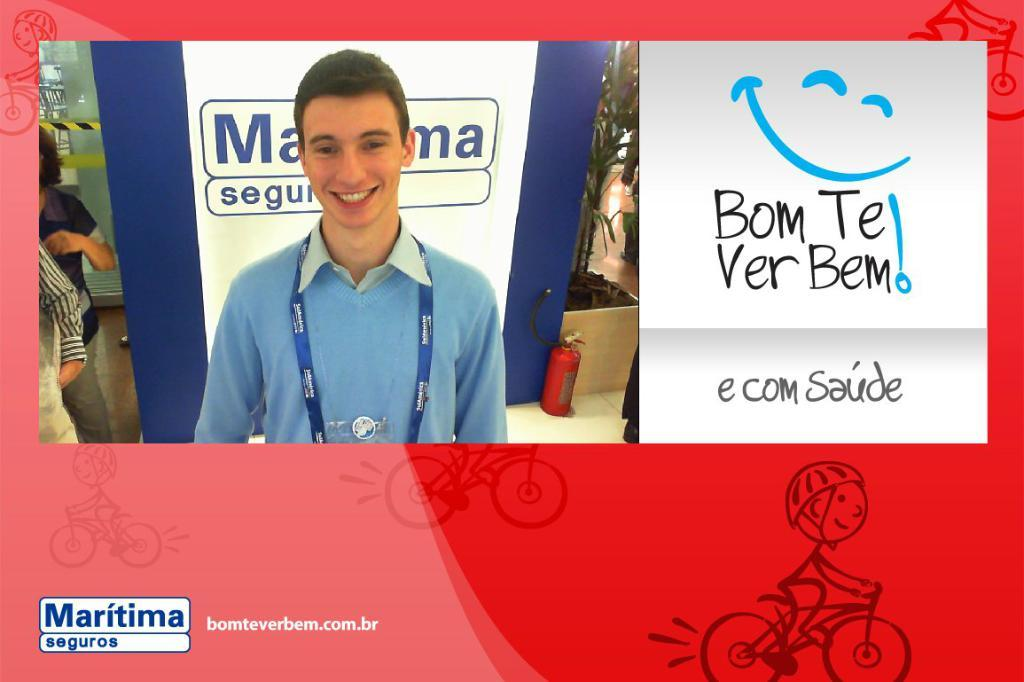<image>
Provide a brief description of the given image. a man smiling with a maritima logo in the bottom left 